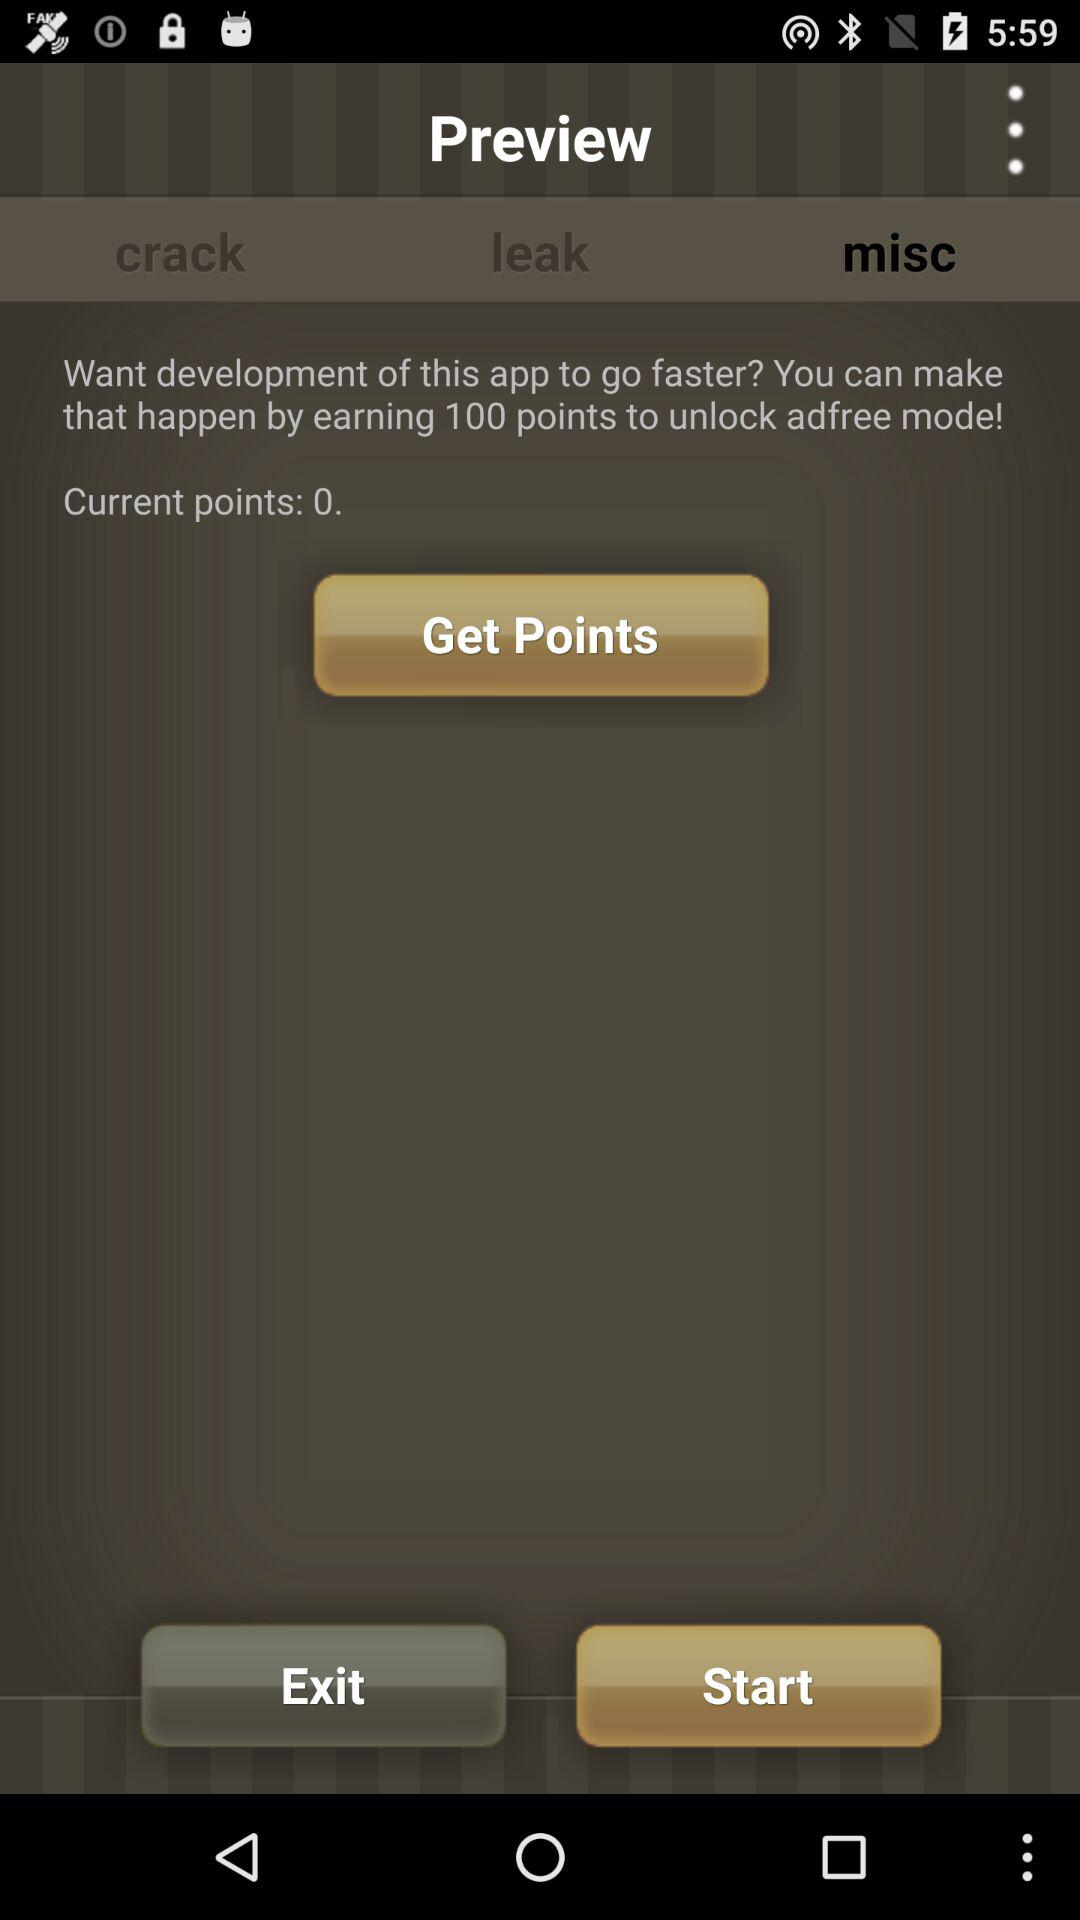How many more points do I need to unlock ad-free mode?
Answer the question using a single word or phrase. 100 